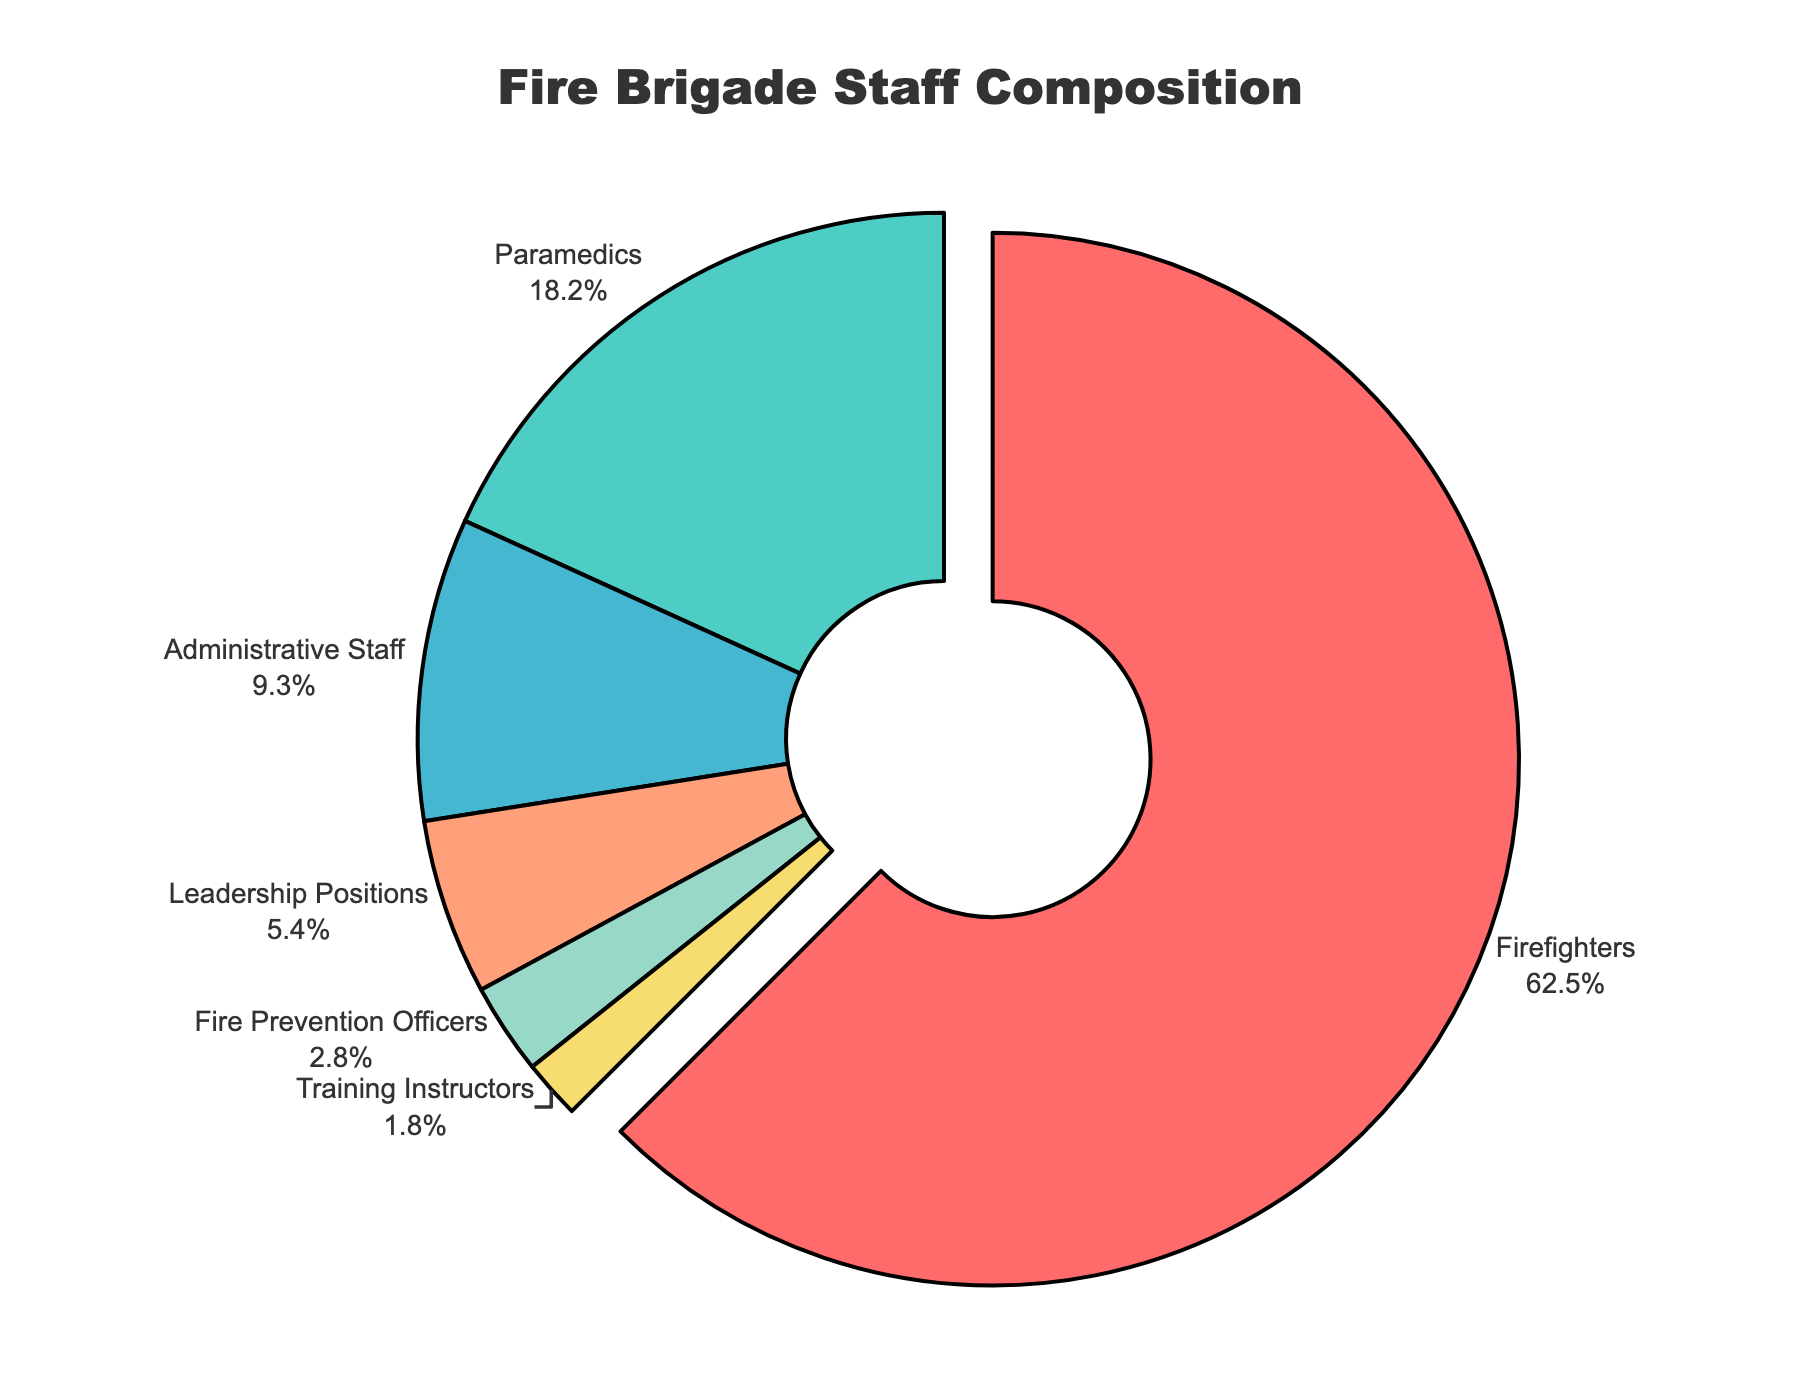What percentage of fire brigade staff are in roles other than firefighters? To determine the percentage of fire brigade staff in roles other than firefighters, subtract the percentage of firefighters from 100%: 100 - 62.5 = 37.5%
Answer: 37.5% Which role has the smallest proportion of staff, and what is this percentage? The role with the smallest proportion is the one with the lowest percentage. In the figure, Training Instructors have 1.8%, which is the smallest percentage.
Answer: Training Instructors, 1.8% How does the proportion of paramedics compare to that of administrative staff? Compare the percentage of paramedics (18.2%) with the percentage of administrative staff (9.3%). Since 18.2% is greater than 9.3%, paramedics have a higher proportion.
Answer: Paramedics have a higher proportion What is the combined percentage of staff in leadership positions and fire prevention officers? Add the percentages of leadership positions (5.4%) and fire prevention officers (2.8%): 5.4 + 2.8 = 8.2%
Answer: 8.2% Are there more firefighters or paramedics and administrative staff combined? Compare 62.5% (firefighters) with the combined percentage of paramedics (18.2%) and administrative staff (9.3%): 18.2 + 9.3 = 27.5%. 62.5% is greater than 27.5%.
Answer: More firefighters What role occupies the biggest segment of the pie chart, and what is the percentage for that role? Identify the largest segment in the pie chart. Firefighters have the largest segment with a percentage of 62.5%.
Answer: Firefighters, 62.5% How many more percentage points are there of firefighters compared to paramedics? Subtract the percentage of paramedics (18.2%) from the percentage of firefighters (62.5%): 62.5 - 18.2 = 44.3 percentage points
Answer: 44.3 percentage points What is the difference in percentage between the smallest role and the second smallest role? Subtract the percentage of the smallest role, Training Instructors (1.8%), from the second smallest role, Fire Prevention Officers (2.8%): 2.8 - 1.8 = 1%
Answer: 1% Which colored slice represents the leadership positions, and what is the proportion of this role? The leadership positions' slice is visually represented as the fourth slice which is a shade of light orange. The proportion is 5.4%.
Answer: Light orange, 5.4% How much more prevalent are firefighters than fire prevention officers? Subtract the percentage of fire prevention officers (2.8%) from firefighters (62.5%): 62.5 - 2.8 = 59.7%
Answer: 59.7% 